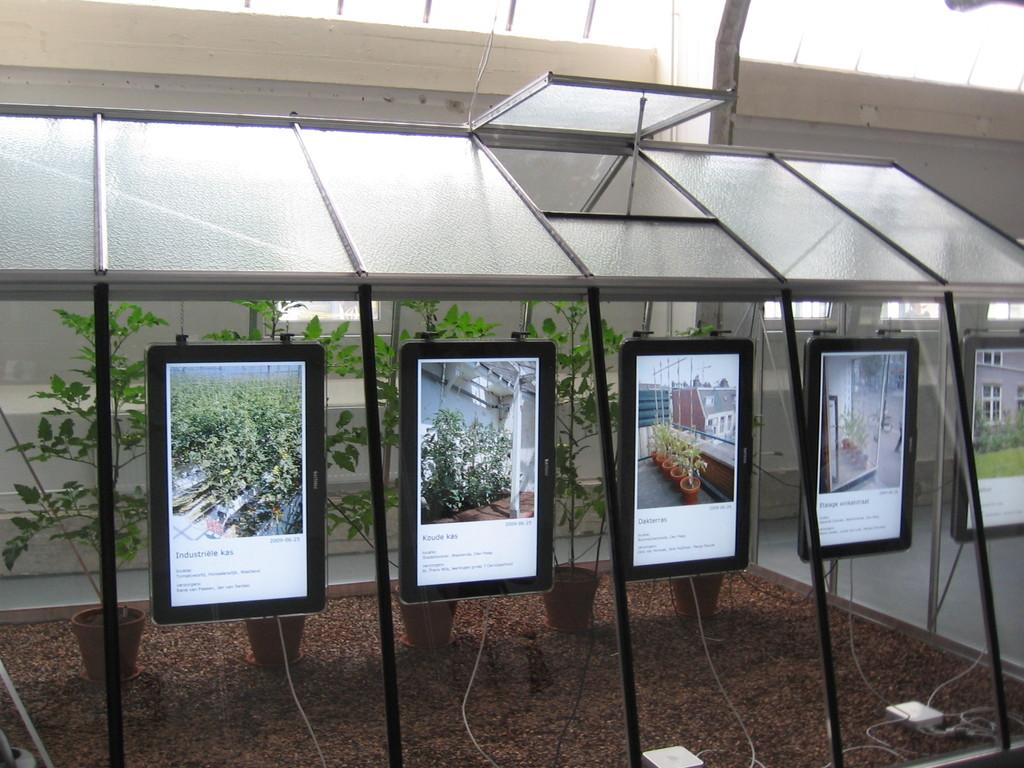What objects can be seen in the image? There are tablets in the image. What structure is located at the top of the image? There is a shed at the top of the image. What type of plants are visible in the image? Houseplants are visible in the image. What can be seen at the bottom of the image? There are wires at the bottom of the image. What is visible in the background of the image? There is a building and grass in the background of the image. What type of cent is visible in the image? There is no cent present in the image. What does the nation in the image represent? There is no nation depicted in the image. 